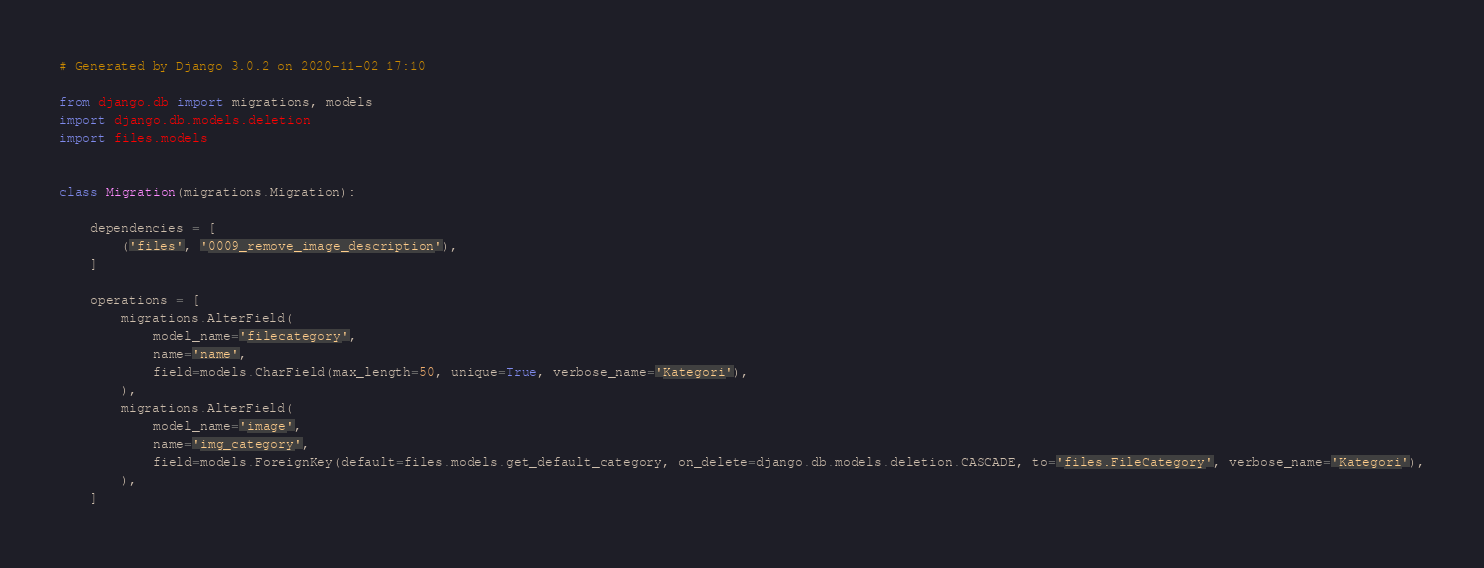<code> <loc_0><loc_0><loc_500><loc_500><_Python_># Generated by Django 3.0.2 on 2020-11-02 17:10

from django.db import migrations, models
import django.db.models.deletion
import files.models


class Migration(migrations.Migration):

    dependencies = [
        ('files', '0009_remove_image_description'),
    ]

    operations = [
        migrations.AlterField(
            model_name='filecategory',
            name='name',
            field=models.CharField(max_length=50, unique=True, verbose_name='Kategori'),
        ),
        migrations.AlterField(
            model_name='image',
            name='img_category',
            field=models.ForeignKey(default=files.models.get_default_category, on_delete=django.db.models.deletion.CASCADE, to='files.FileCategory', verbose_name='Kategori'),
        ),
    ]
</code> 